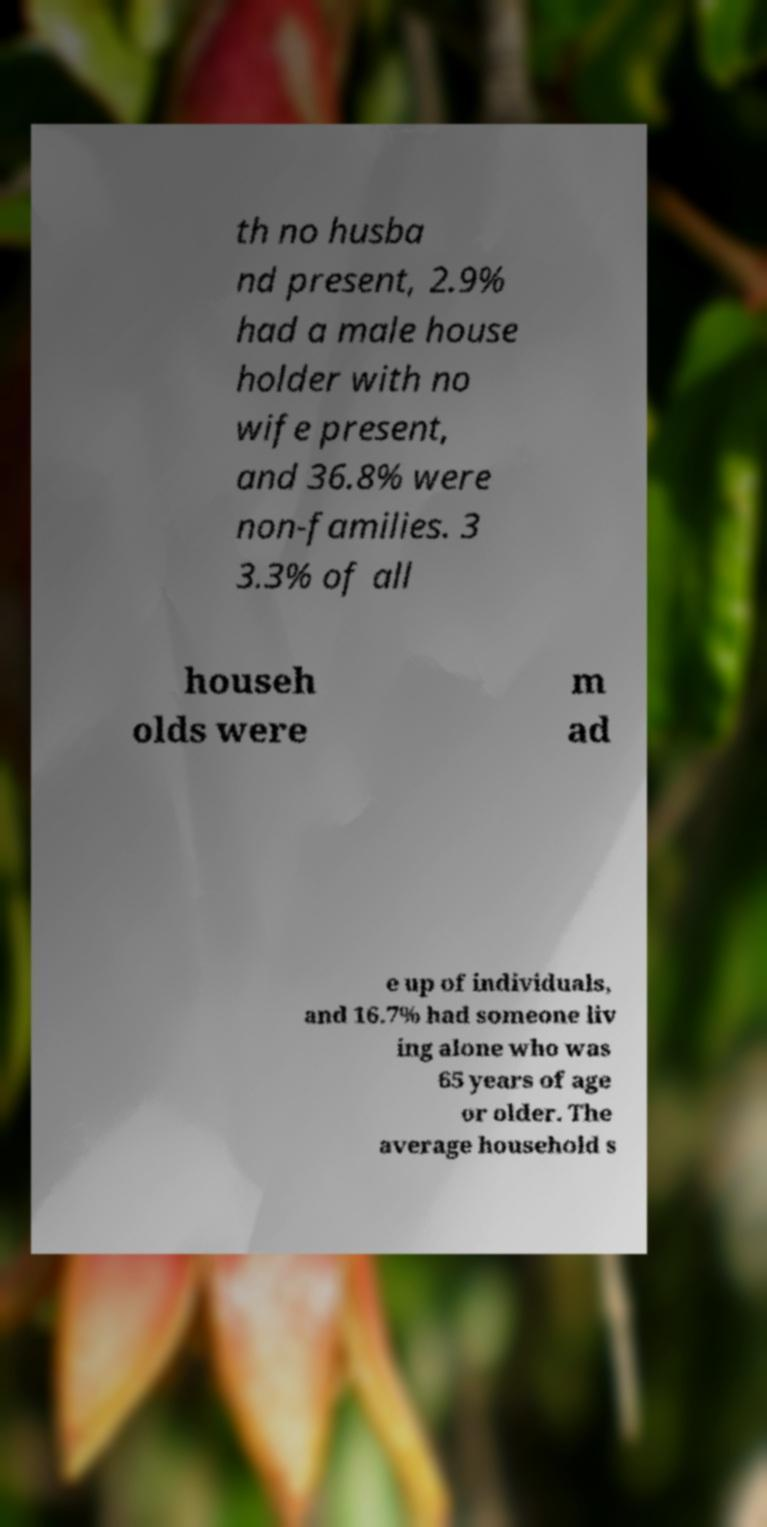There's text embedded in this image that I need extracted. Can you transcribe it verbatim? th no husba nd present, 2.9% had a male house holder with no wife present, and 36.8% were non-families. 3 3.3% of all househ olds were m ad e up of individuals, and 16.7% had someone liv ing alone who was 65 years of age or older. The average household s 